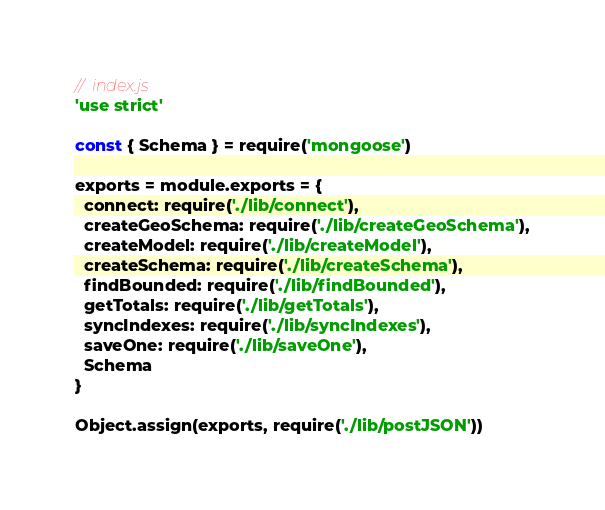Convert code to text. <code><loc_0><loc_0><loc_500><loc_500><_JavaScript_>//  index.js
'use strict'

const { Schema } = require('mongoose')

exports = module.exports = {
  connect: require('./lib/connect'),
  createGeoSchema: require('./lib/createGeoSchema'),
  createModel: require('./lib/createModel'),
  createSchema: require('./lib/createSchema'),
  findBounded: require('./lib/findBounded'),
  getTotals: require('./lib/getTotals'),
  syncIndexes: require('./lib/syncIndexes'),
  saveOne: require('./lib/saveOne'),
  Schema
}

Object.assign(exports, require('./lib/postJSON'))
</code> 